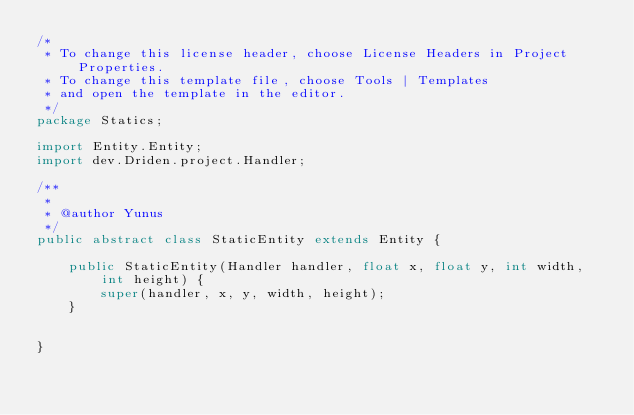<code> <loc_0><loc_0><loc_500><loc_500><_Java_>/*
 * To change this license header, choose License Headers in Project Properties.
 * To change this template file, choose Tools | Templates
 * and open the template in the editor.
 */
package Statics;

import Entity.Entity;
import dev.Driden.project.Handler;

/**
 *
 * @author Yunus
 */
public abstract class StaticEntity extends Entity {

    public StaticEntity(Handler handler, float x, float y, int width, int height) {
        super(handler, x, y, width, height);
    }
    
    
}
</code> 